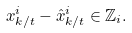Convert formula to latex. <formula><loc_0><loc_0><loc_500><loc_500>x ^ { i } _ { k / t } - \hat { x } ^ { i } _ { k / t } \in \mathbb { Z } _ { i } .</formula> 